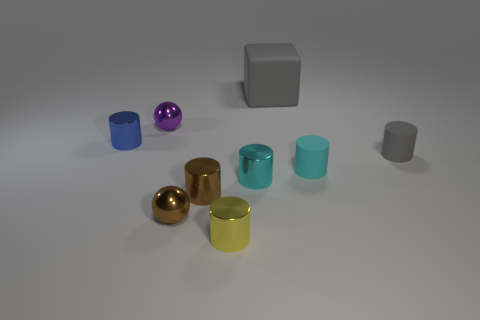There is a cylinder that is on the right side of the tiny cyan matte cylinder; how many metal cylinders are in front of it?
Give a very brief answer. 3. What number of other small purple things have the same material as the purple thing?
Offer a terse response. 0. There is a yellow shiny object; are there any small spheres to the right of it?
Provide a short and direct response. No. What is the color of the sphere that is the same size as the purple thing?
Your response must be concise. Brown. How many objects are small shiny things that are in front of the purple shiny thing or blue things?
Provide a short and direct response. 5. There is a cylinder that is on the left side of the small cyan matte cylinder and behind the small cyan metal cylinder; how big is it?
Your response must be concise. Small. What size is the rubber cylinder that is the same color as the big rubber block?
Your answer should be compact. Small. What number of other objects are there of the same size as the yellow metal object?
Give a very brief answer. 7. There is a small metal cylinder behind the small matte cylinder on the right side of the small cyan cylinder right of the gray matte block; what is its color?
Your response must be concise. Blue. What is the shape of the small object that is both on the left side of the large gray cube and on the right side of the small yellow cylinder?
Keep it short and to the point. Cylinder. 